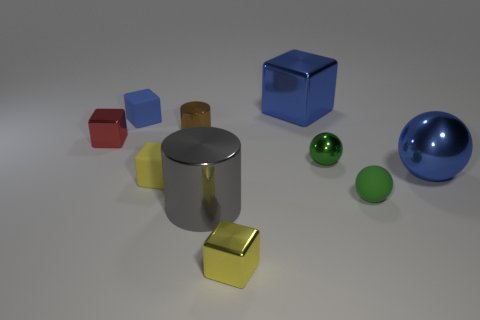Subtract 1 cubes. How many cubes are left? 4 Subtract all brown spheres. Subtract all cyan cylinders. How many spheres are left? 3 Subtract all cylinders. How many objects are left? 8 Add 6 tiny metal things. How many tiny metal things are left? 10 Add 4 large shiny things. How many large shiny things exist? 7 Subtract 0 cyan balls. How many objects are left? 10 Subtract all tiny yellow metal objects. Subtract all small green metal spheres. How many objects are left? 8 